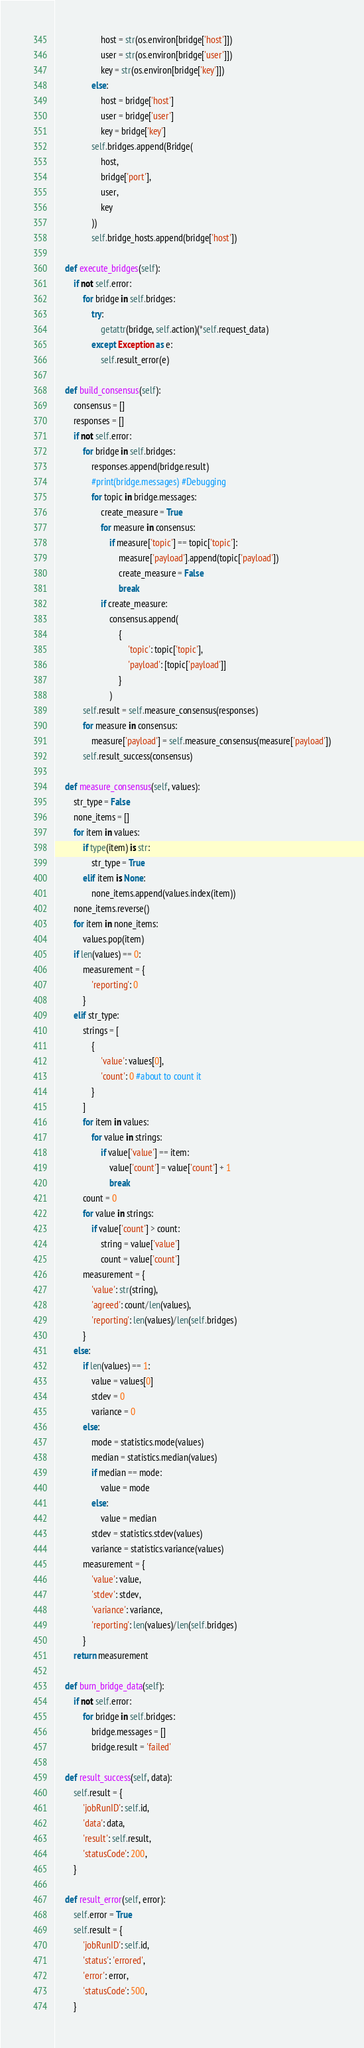Convert code to text. <code><loc_0><loc_0><loc_500><loc_500><_Python_>                    host = str(os.environ[bridge['host']])    
                    user = str(os.environ[bridge['user']])
                    key = str(os.environ[bridge['key']])
                else:
                    host = bridge['host']
                    user = bridge['user']
                    key = bridge['key']
                self.bridges.append(Bridge(
                    host, 
                    bridge['port'],
                    user,
                    key
                ))
                self.bridge_hosts.append(bridge['host'])

    def execute_bridges(self):
        if not self.error:
            for bridge in self.bridges:
                try:
                    getattr(bridge, self.action)(*self.request_data)
                except Exception as e:
                    self.result_error(e)

    def build_consensus(self):
        consensus = []
        responses = []
        if not self.error:
            for bridge in self.bridges:
                responses.append(bridge.result)
                #print(bridge.messages) #Debugging
                for topic in bridge.messages:
                    create_measure = True
                    for measure in consensus:
                        if measure['topic'] == topic['topic']:
                            measure['payload'].append(topic['payload'])
                            create_measure = False
                            break
                    if create_measure:
                        consensus.append(
                            {
                                'topic': topic['topic'],
                                'payload': [topic['payload']]
                            }
                        )
            self.result = self.measure_consensus(responses)
            for measure in consensus:
                measure['payload'] = self.measure_consensus(measure['payload'])
            self.result_success(consensus)

    def measure_consensus(self, values):
        str_type = False
        none_items = []
        for item in values:
            if type(item) is str:
                str_type = True
            elif item is None:
                none_items.append(values.index(item))
        none_items.reverse()
        for item in none_items:
            values.pop(item)
        if len(values) == 0:
            measurement = {
                'reporting': 0
            }
        elif str_type:
            strings = [
                {
                    'value': values[0],
                    'count': 0 #about to count it
                }
            ]
            for item in values:
                for value in strings:
                    if value['value'] == item:
                        value['count'] = value['count'] + 1
                        break
            count = 0
            for value in strings:
                if value['count'] > count:
                    string = value['value']
                    count = value['count']
            measurement = {
                'value': str(string),
                'agreed': count/len(values),
                'reporting': len(values)/len(self.bridges)
            }
        else:
            if len(values) == 1:
                value = values[0]
                stdev = 0
                variance = 0
            else:
                mode = statistics.mode(values)
                median = statistics.median(values)
                if median == mode:
                    value = mode
                else:
                    value = median
                stdev = statistics.stdev(values)
                variance = statistics.variance(values)
            measurement = {
                'value': value,
                'stdev': stdev,
                'variance': variance,
                'reporting': len(values)/len(self.bridges)
            }
        return measurement

    def burn_bridge_data(self):
        if not self.error:
            for bridge in self.bridges:
                bridge.messages = []
                bridge.result = 'failed'

    def result_success(self, data):
        self.result = {
            'jobRunID': self.id,
            'data': data,
            'result': self.result,
            'statusCode': 200,
        }

    def result_error(self, error):
        self.error = True
        self.result = {
            'jobRunID': self.id,
            'status': 'errored',
            'error': error,
            'statusCode': 500,
        }</code> 